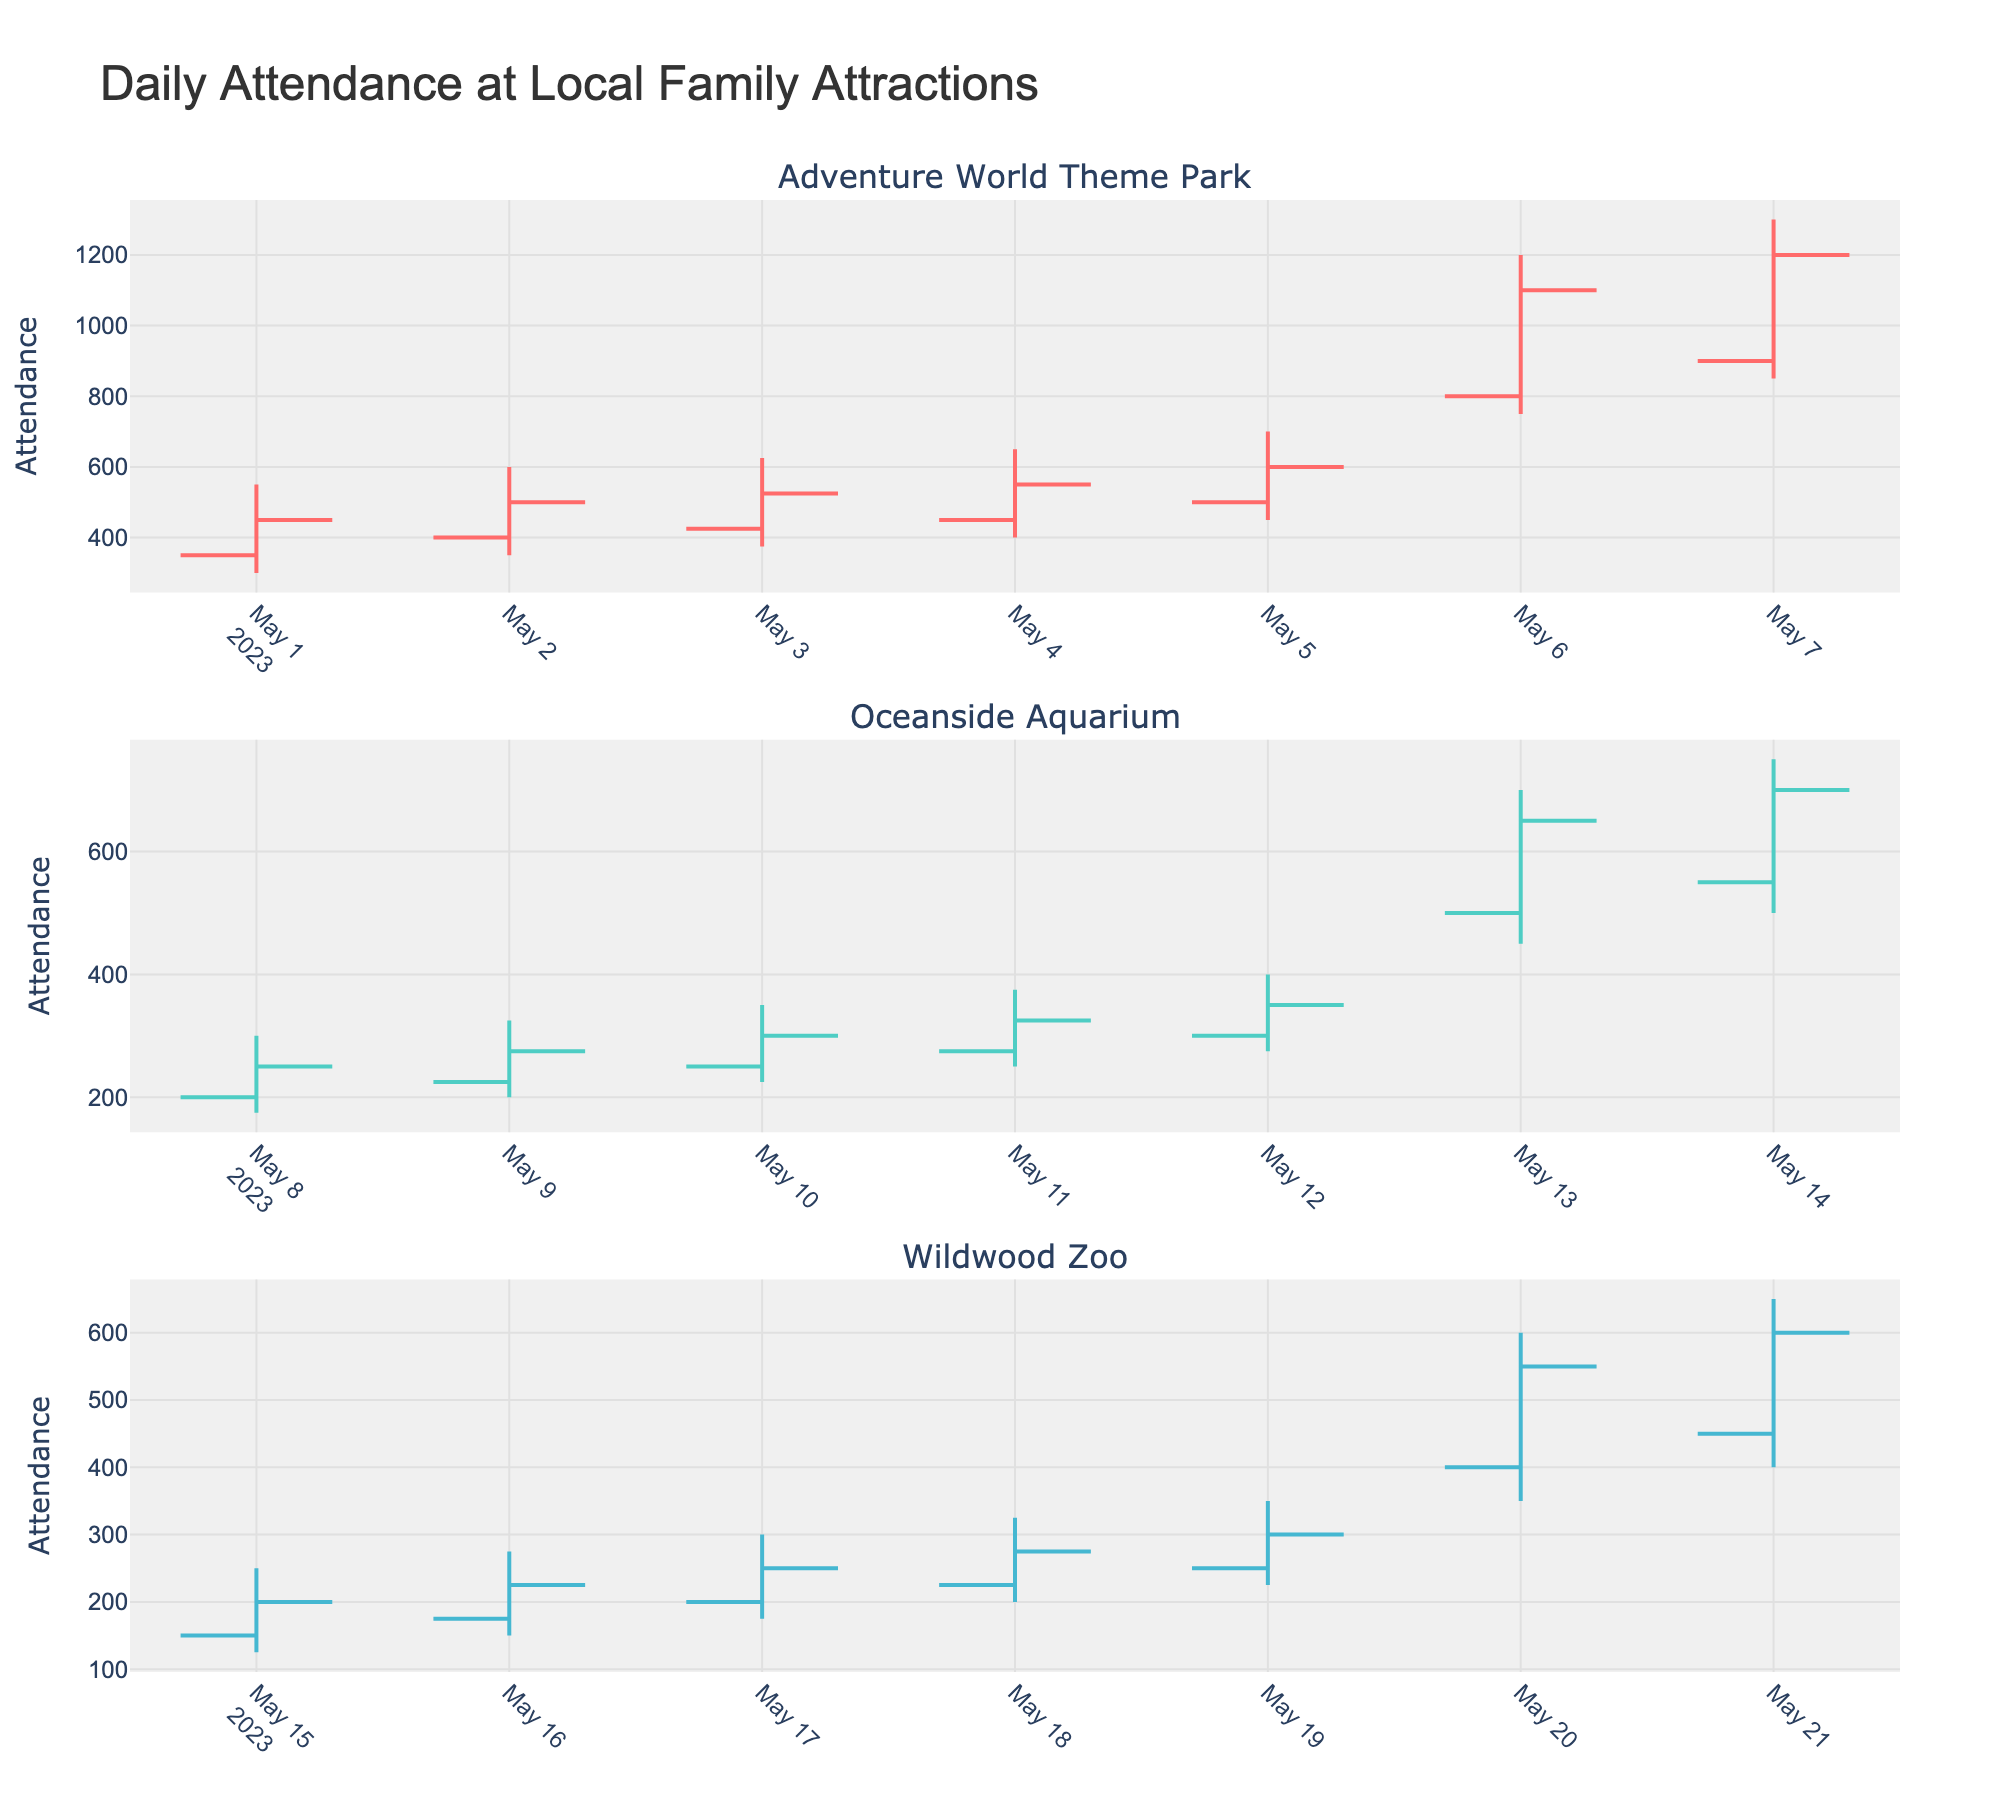What's the title of the chart? The title of the chart is displayed at the top. It reads "Daily Attendance at Local Family Attractions."
Answer: Daily Attendance at Local Family Attractions How many different attractions are displayed? There are subplots for each attraction. By counting the subplot titles, we see there are three attractions: "Adventure World Theme Park," "Oceanside Aquarium," and "Wildwood Zoo."
Answer: Three Which attraction has the highest peak attendance on any single day? Look for the highest value in the 'High' column for each attraction. "Adventure World Theme Park" reaches a maximum attendance of 1300 on 2023-05-07.
Answer: Adventure World Theme Park On which days do we see a noticeable increase or decrease in attendance for Adventure World Theme Park due to weekends? Compare the attendance between weekdays and weekends. On weekends (2023-05-06 and 2023-05-07), the theme park sees a significant increase in attendance with highs of 1200 and 1300, compared to weekdays where the highest is 700.
Answer: 2023-05-06 and 2023-05-07 What is the range of attendance at Oceanside Aquarium on 2023-05-13? The range is calculated by subtracting the 'Low' from the 'High' values. For 2023-05-13, it's 700 - 450 = 250.
Answer: 250 Which attraction has the lowest attendance on a weekday, and what is the value? Look for the lowest 'Low' values among weekdays. Wildwood Zoo on 2023-05-15 has the lowest attendance of 125.
Answer: Wildwood Zoo, 125 How does the attendance trend differ between weekdays and weekends for Wildwood Zoo? Compare the attendance 'High' and 'Low' between weekdays and weekends. Weekends (2023-05-20, 2023-05-21) have higher attendance values (Highs: 600, 650) compared to weekdays which range from 250 to 350 in 'High.'
Answer: Higher on weekends What pattern do you observe in the close attendance values for Oceanside Aquarium over the weekdays? The close values show an increasing trend from 250 on 2023-05-08 to 350 on 2023-05-12.
Answer: Increasing trend Which attraction shows the most significant difference in attendance between weekdays and weekends? Calculate the differences in 'High' values between weekends and weekdays for each attraction. Adventure World Theme Park shows the most significant change, going from a weekday high of 700 to a weekend high of 1300.
Answer: Adventure World Theme Park 